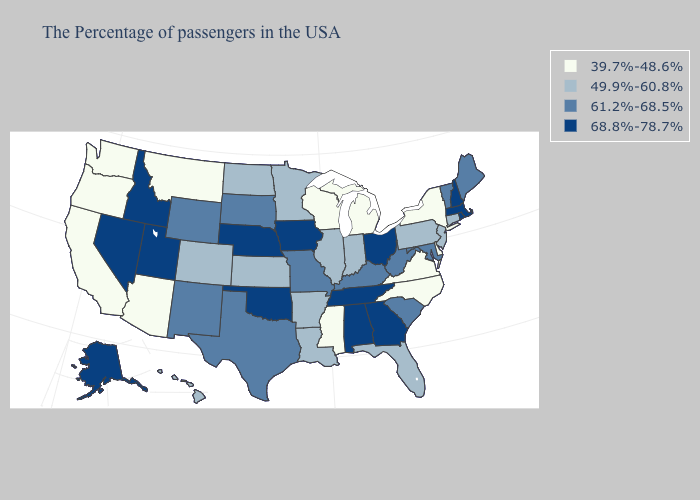Among the states that border Nebraska , which have the lowest value?
Answer briefly. Kansas, Colorado. Which states have the lowest value in the USA?
Short answer required. New York, Delaware, Virginia, North Carolina, Michigan, Wisconsin, Mississippi, Montana, Arizona, California, Washington, Oregon. Among the states that border New Hampshire , does Maine have the highest value?
Concise answer only. No. Among the states that border Connecticut , which have the lowest value?
Quick response, please. New York. Which states have the lowest value in the West?
Concise answer only. Montana, Arizona, California, Washington, Oregon. Does Virginia have the lowest value in the South?
Answer briefly. Yes. What is the lowest value in states that border Georgia?
Concise answer only. 39.7%-48.6%. Which states hav the highest value in the Northeast?
Answer briefly. Massachusetts, Rhode Island, New Hampshire. What is the value of Tennessee?
Quick response, please. 68.8%-78.7%. What is the value of Maine?
Keep it brief. 61.2%-68.5%. How many symbols are there in the legend?
Answer briefly. 4. What is the value of North Dakota?
Give a very brief answer. 49.9%-60.8%. What is the value of Idaho?
Keep it brief. 68.8%-78.7%. Name the states that have a value in the range 39.7%-48.6%?
Concise answer only. New York, Delaware, Virginia, North Carolina, Michigan, Wisconsin, Mississippi, Montana, Arizona, California, Washington, Oregon. What is the highest value in the South ?
Quick response, please. 68.8%-78.7%. 